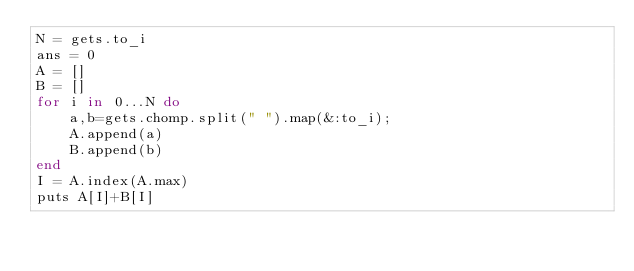<code> <loc_0><loc_0><loc_500><loc_500><_Ruby_>N = gets.to_i
ans = 0
A = []
B = []
for i in 0...N do
    a,b=gets.chomp.split(" ").map(&:to_i);
    A.append(a)
    B.append(b)
end
I = A.index(A.max)
puts A[I]+B[I]</code> 